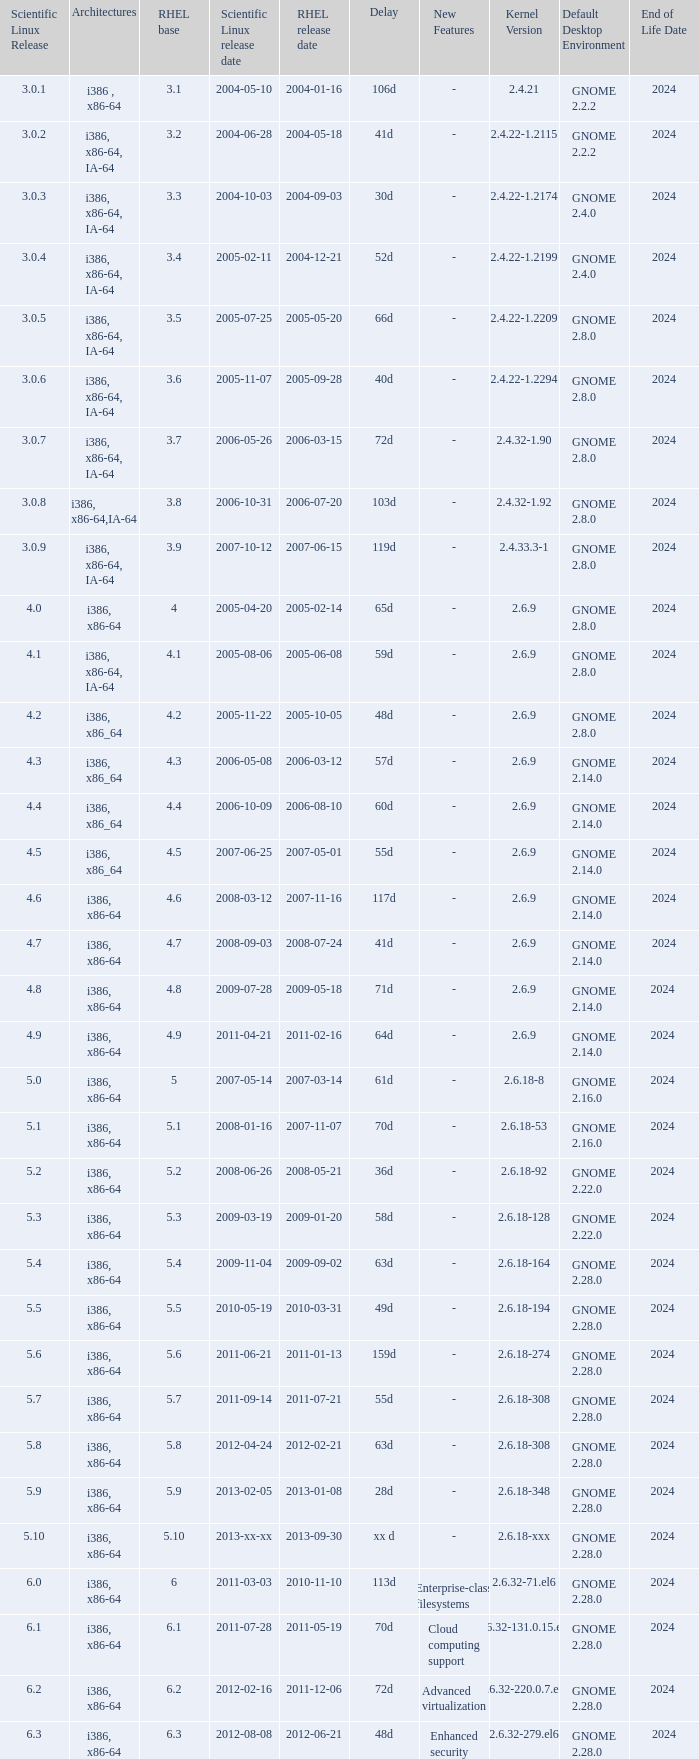Name the delay when scientific linux release is 5.10 Xx d. 